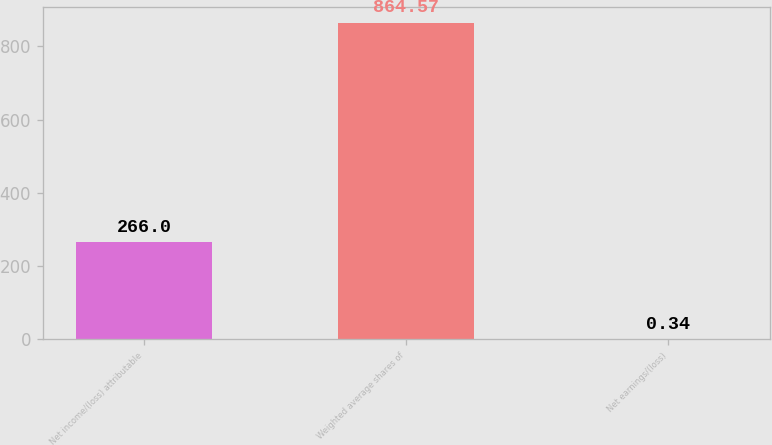Convert chart to OTSL. <chart><loc_0><loc_0><loc_500><loc_500><bar_chart><fcel>Net income/(loss) attributable<fcel>Weighted average shares of<fcel>Net earnings/(loss)<nl><fcel>266<fcel>864.57<fcel>0.34<nl></chart> 